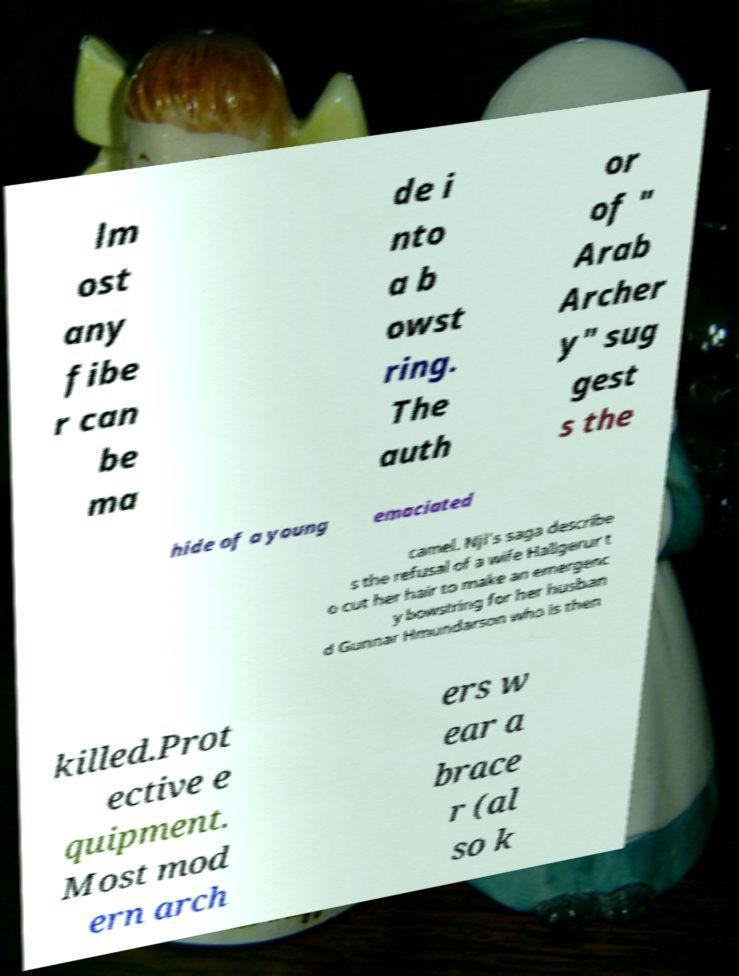Can you read and provide the text displayed in the image?This photo seems to have some interesting text. Can you extract and type it out for me? lm ost any fibe r can be ma de i nto a b owst ring. The auth or of " Arab Archer y" sug gest s the hide of a young emaciated camel. Njl's saga describe s the refusal of a wife Hallgerur t o cut her hair to make an emergenc y bowstring for her husban d Gunnar Hmundarson who is then killed.Prot ective e quipment. Most mod ern arch ers w ear a brace r (al so k 